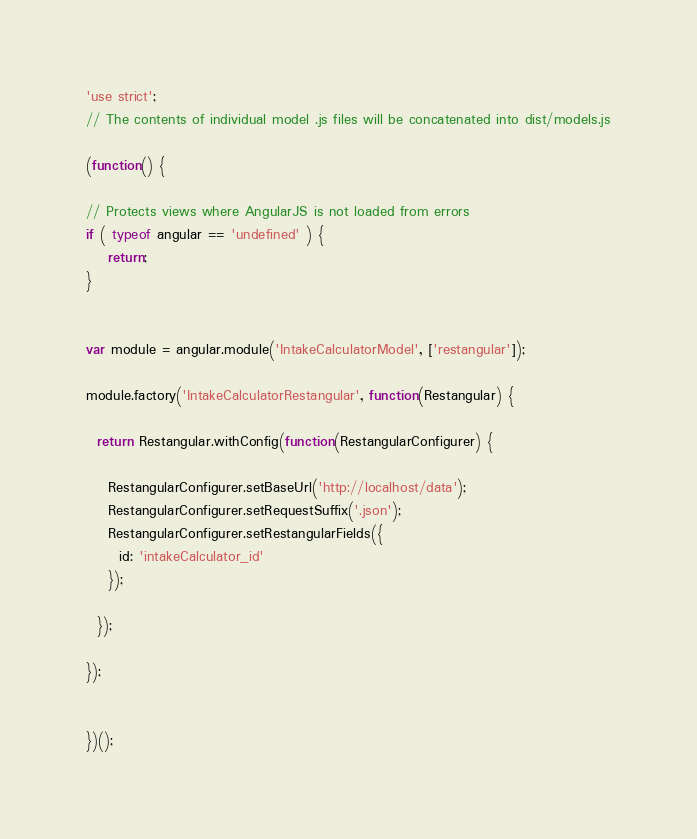Convert code to text. <code><loc_0><loc_0><loc_500><loc_500><_JavaScript_>'use strict';
// The contents of individual model .js files will be concatenated into dist/models.js

(function() {

// Protects views where AngularJS is not loaded from errors
if ( typeof angular == 'undefined' ) {
	return;
}


var module = angular.module('IntakeCalculatorModel', ['restangular']);

module.factory('IntakeCalculatorRestangular', function(Restangular) {

  return Restangular.withConfig(function(RestangularConfigurer) {

    RestangularConfigurer.setBaseUrl('http://localhost/data');
    RestangularConfigurer.setRequestSuffix('.json');
    RestangularConfigurer.setRestangularFields({
      id: 'intakeCalculator_id'
    });

  });

});


})();
</code> 